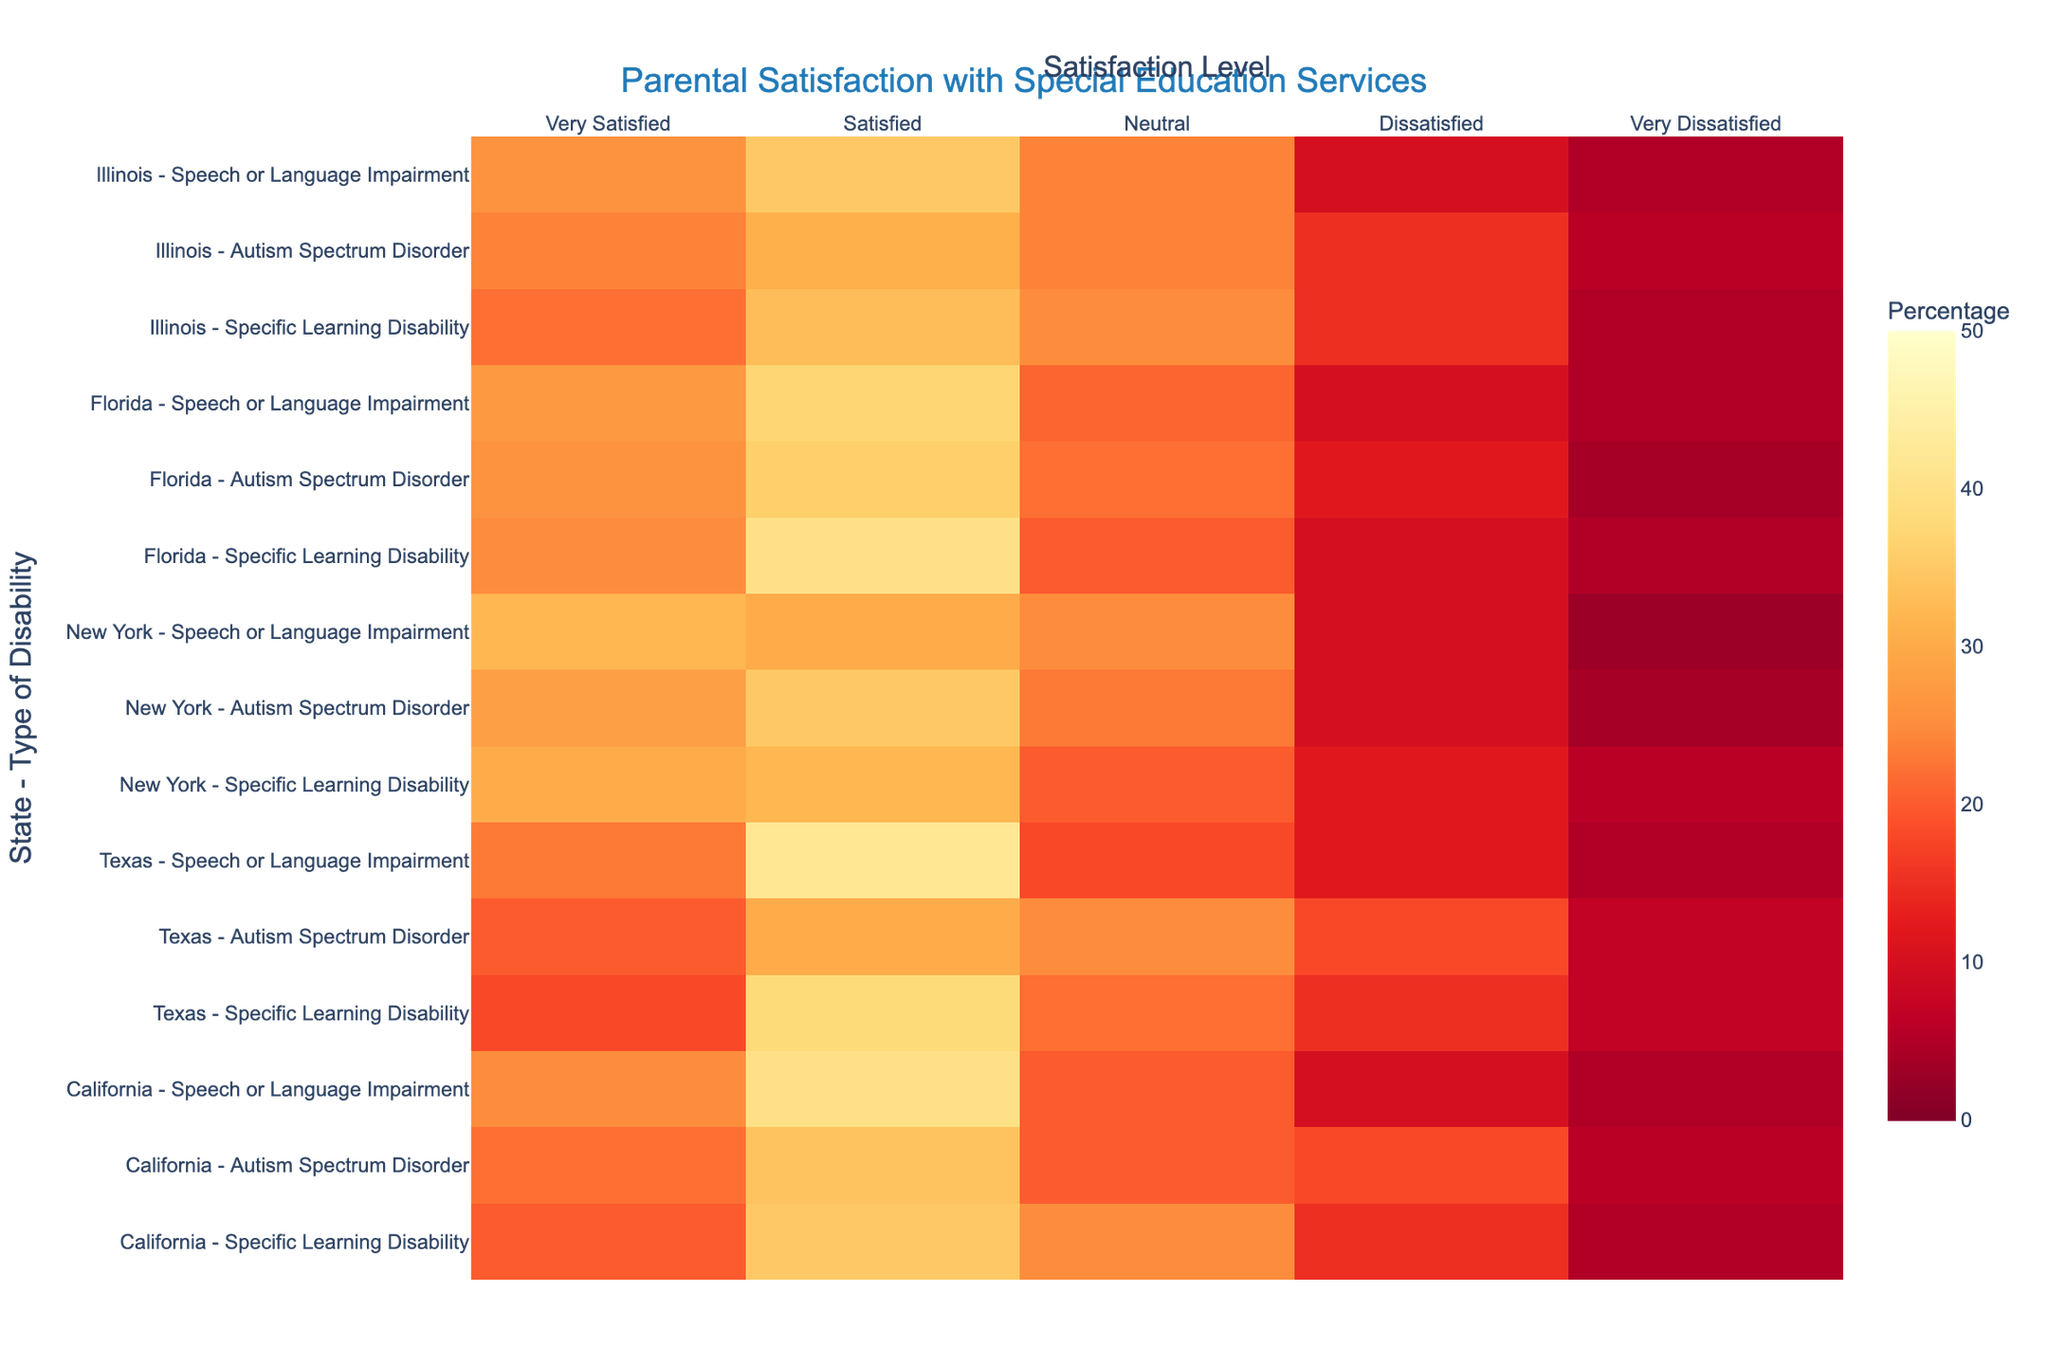Which state has the highest percentage of 'Very Satisfied' parents for Specific Learning Disability? Identify the percentage values for 'Very Satisfied' in the heatmap for Specific Learning Disability across all states. California has 20, Texas has 18, New York has 30, Florida has 25, and Illinois has 22. Thus, New York has the highest percentage.
Answer: New York What is the average percentage of 'Satisfied' parents across all states for Autism Spectrum Disorder? List the percentage values for 'Satisfied' under Autism Spectrum Disorder: California (34), Texas (30), New York (35), Florida (36), Illinois (31). Sum these (34 + 30 + 35 + 36 + 31 = 166) and divide by the number of states (5). 166/5 = 33.2.
Answer: 33.2 Which type of disability has the highest 'Very Dissatisfied' percentage in Texas? For Texas, compare the 'Very Dissatisfied' percentages: Specific Learning Disability (7), Autism Spectrum Disorder (7), and Speech or Language Impairment (5). Both Specific Learning Disability and Autism Spectrum Disorder have the highest percentage of 7.
Answer: Specific Learning Disability and Autism Spectrum Disorder Are there more states with a higher 'Neutral' satisfaction level for Speech or Language Impairment or for Specific Learning Disability? Compare the 'Neutral' percentages for both disabilities across states. For Speech or Language Impairment: California (20), Texas (18), New York (25), Florida (21), Illinois (24). For Specific Learning Disability: California (25), Texas (22), New York (20), Florida (20), Illinois (25). Count the states where Speech or Language Impairment exceeds Specific Learning Disability. Speech or Language Impairment (3: Texas, New York, Florida), Specific Learning Disability (2: California, Illinois).
Answer: Speech or Language Impairment Which state shows the highest dissatisfaction (sum of 'Dissatisfied' and 'Very Dissatisfied') for Autism Spectrum Disorder? Compute the sums: California (18 + 6 = 24), Texas (18 + 7 = 25), New York (10 + 4 = 14), Florida (12 + 4 = 16), Illinois (15 + 6 = 21). Texas has the highest sum of dissatisfaction at 25.
Answer: Texas 